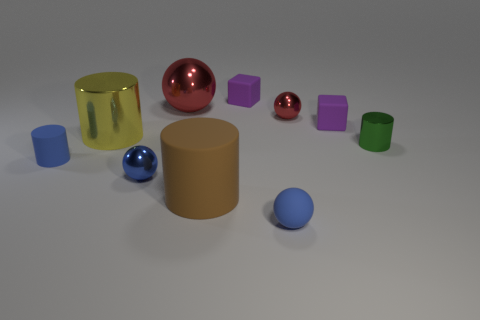Subtract all blocks. How many objects are left? 8 Subtract all green metal things. Subtract all tiny cyan spheres. How many objects are left? 9 Add 2 blue things. How many blue things are left? 5 Add 6 matte spheres. How many matte spheres exist? 7 Subtract 0 gray cylinders. How many objects are left? 10 